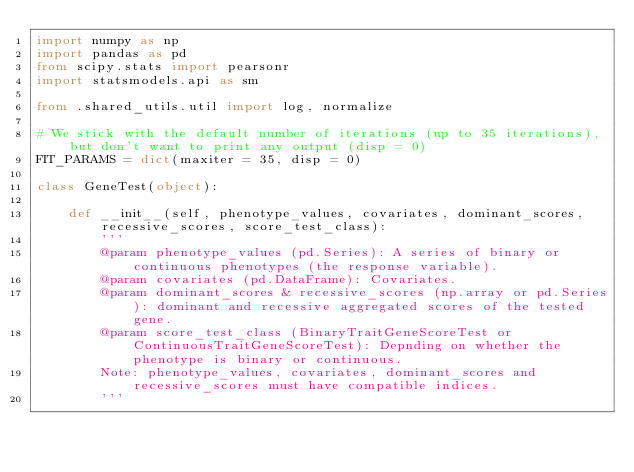<code> <loc_0><loc_0><loc_500><loc_500><_Python_>import numpy as np
import pandas as pd
from scipy.stats import pearsonr
import statsmodels.api as sm

from .shared_utils.util import log, normalize

# We stick with the default number of iterations (up to 35 iterations), but don't want to print any output (disp = 0)
FIT_PARAMS = dict(maxiter = 35, disp = 0)

class GeneTest(object):

    def __init__(self, phenotype_values, covariates, dominant_scores, recessive_scores, score_test_class):
        '''
        @param phenotype_values (pd.Series): A series of binary or continuous phenotypes (the response variable).
        @param covariates (pd.DataFrame): Covariates.
        @param dominant_scores & recessive_scores (np.array or pd.Series): dominant and recessive aggregated scores of the tested gene.
        @param score_test_class (BinaryTraitGeneScoreTest or ContinuousTraitGeneScoreTest): Depnding on whether the phenotype is binary or continuous.
        Note: phenotype_values, covariates, dominant_scores and recessive_scores must have compatible indices.
        '''</code> 